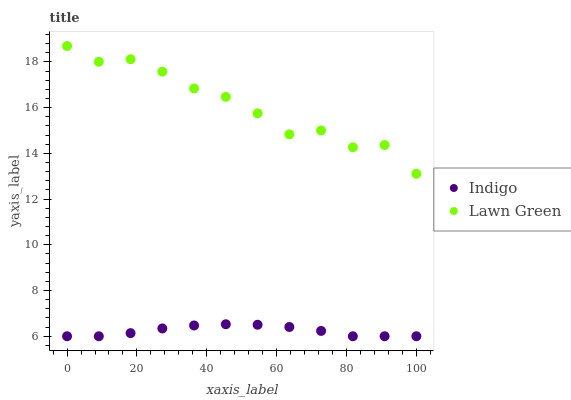Does Indigo have the minimum area under the curve?
Answer yes or no. Yes. Does Lawn Green have the maximum area under the curve?
Answer yes or no. Yes. Does Indigo have the maximum area under the curve?
Answer yes or no. No. Is Indigo the smoothest?
Answer yes or no. Yes. Is Lawn Green the roughest?
Answer yes or no. Yes. Is Indigo the roughest?
Answer yes or no. No. Does Indigo have the lowest value?
Answer yes or no. Yes. Does Lawn Green have the highest value?
Answer yes or no. Yes. Does Indigo have the highest value?
Answer yes or no. No. Is Indigo less than Lawn Green?
Answer yes or no. Yes. Is Lawn Green greater than Indigo?
Answer yes or no. Yes. Does Indigo intersect Lawn Green?
Answer yes or no. No. 